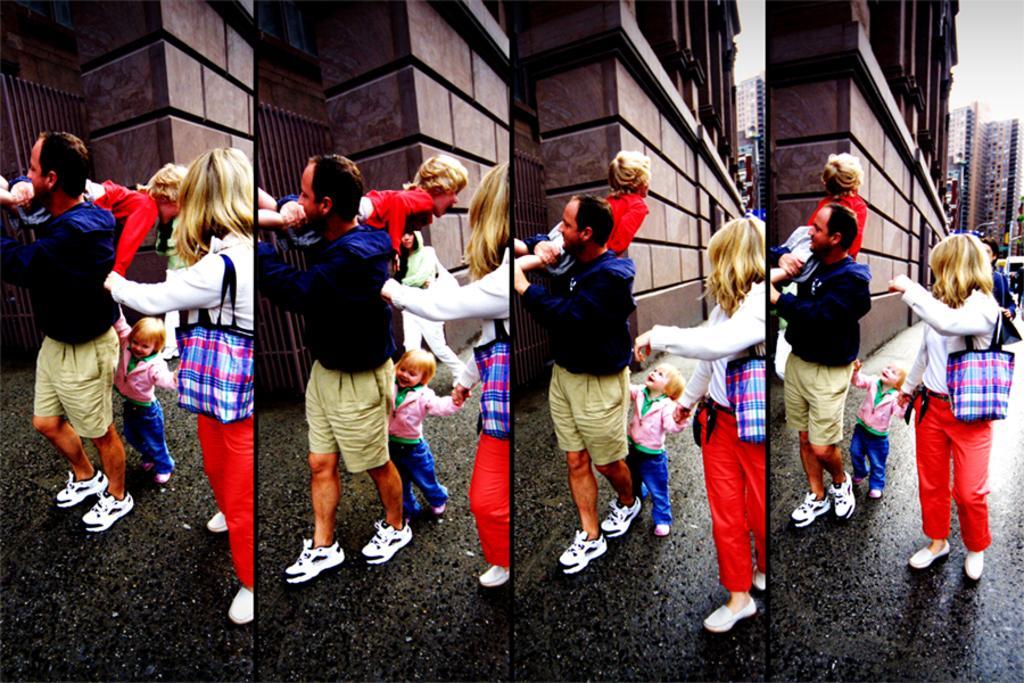In one or two sentences, can you explain what this image depicts? It looks like a collage picture. I can see the man, woman and a kid standing. This man is carrying a boy. In the background, I can see a building with an iron gate. On the right side of the image, I can see few other holdings. 